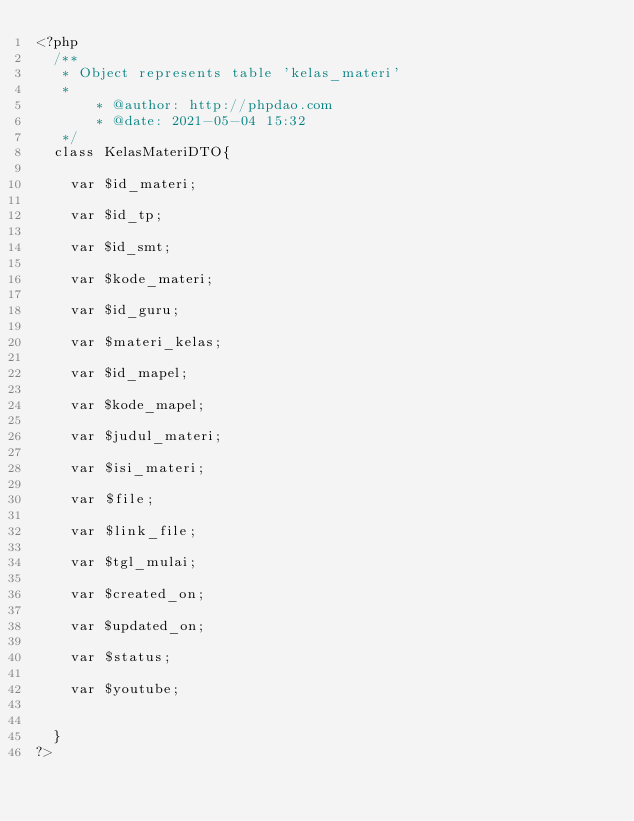Convert code to text. <code><loc_0><loc_0><loc_500><loc_500><_PHP_><?php
	/**
	 * Object represents table 'kelas_materi'
	 *
     	 * @author: http://phpdao.com
     	 * @date: 2021-05-04 15:32	 
	 */
	class KelasMateriDTO{
		
		var $id_materi;
		var $id_tp;
		var $id_smt;
		var $kode_materi;
		var $id_guru;
		var $materi_kelas;
		var $id_mapel;
		var $kode_mapel;
		var $judul_materi;
		var $isi_materi;
		var $file;
		var $link_file;
		var $tgl_mulai;
		var $created_on;
		var $updated_on;
		var $status;
		var $youtube;
		
	}
?></code> 